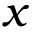Convert formula to latex. <formula><loc_0><loc_0><loc_500><loc_500>x</formula> 